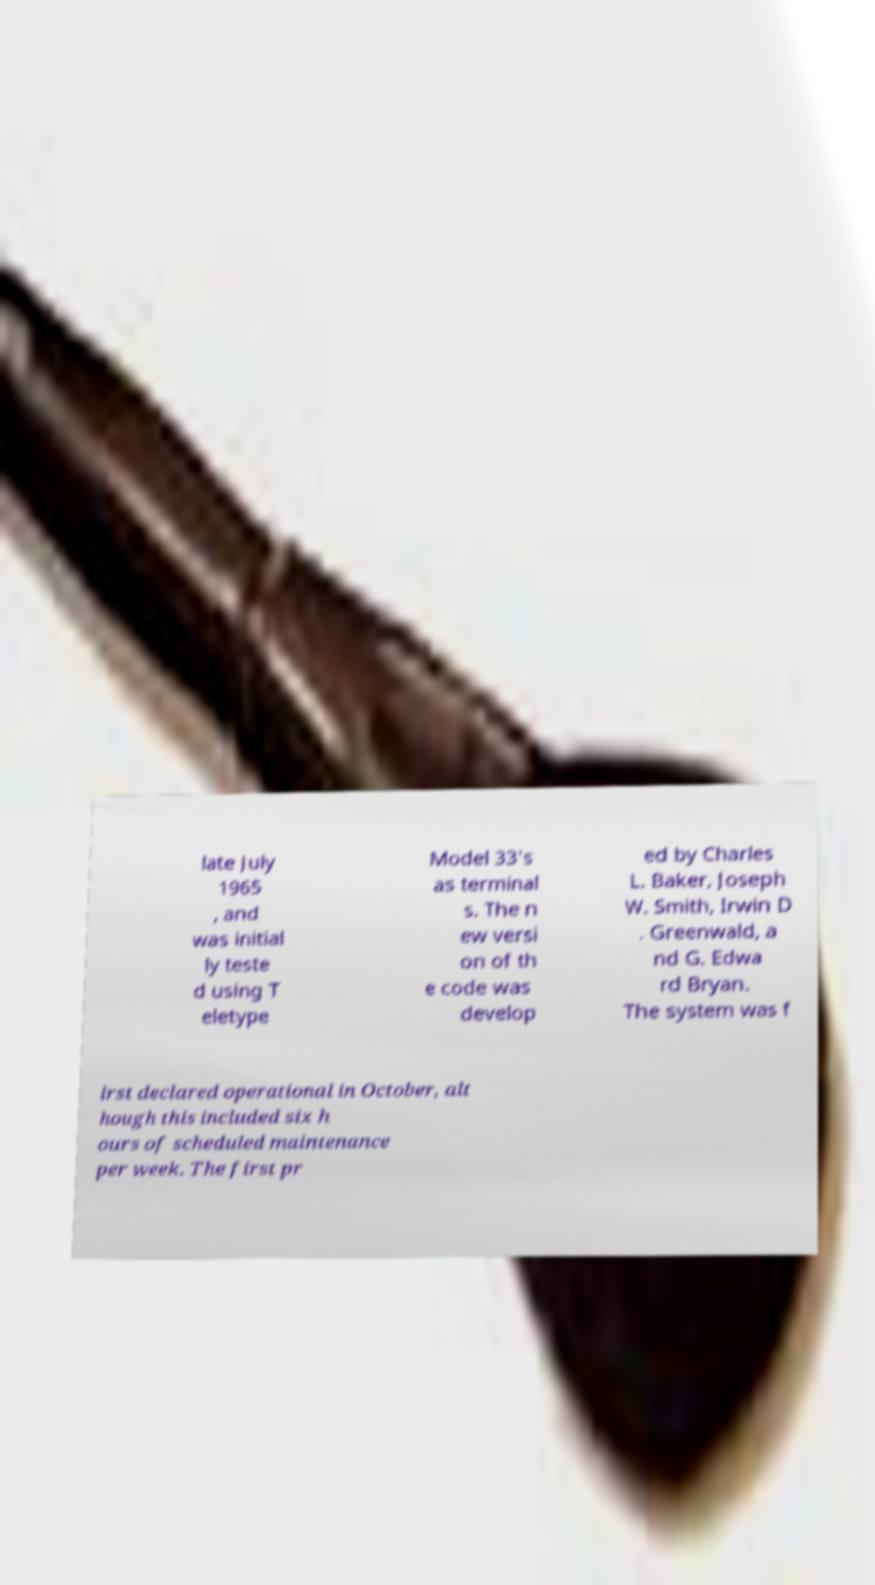Could you assist in decoding the text presented in this image and type it out clearly? late July 1965 , and was initial ly teste d using T eletype Model 33's as terminal s. The n ew versi on of th e code was develop ed by Charles L. Baker, Joseph W. Smith, Irwin D . Greenwald, a nd G. Edwa rd Bryan. The system was f irst declared operational in October, alt hough this included six h ours of scheduled maintenance per week. The first pr 